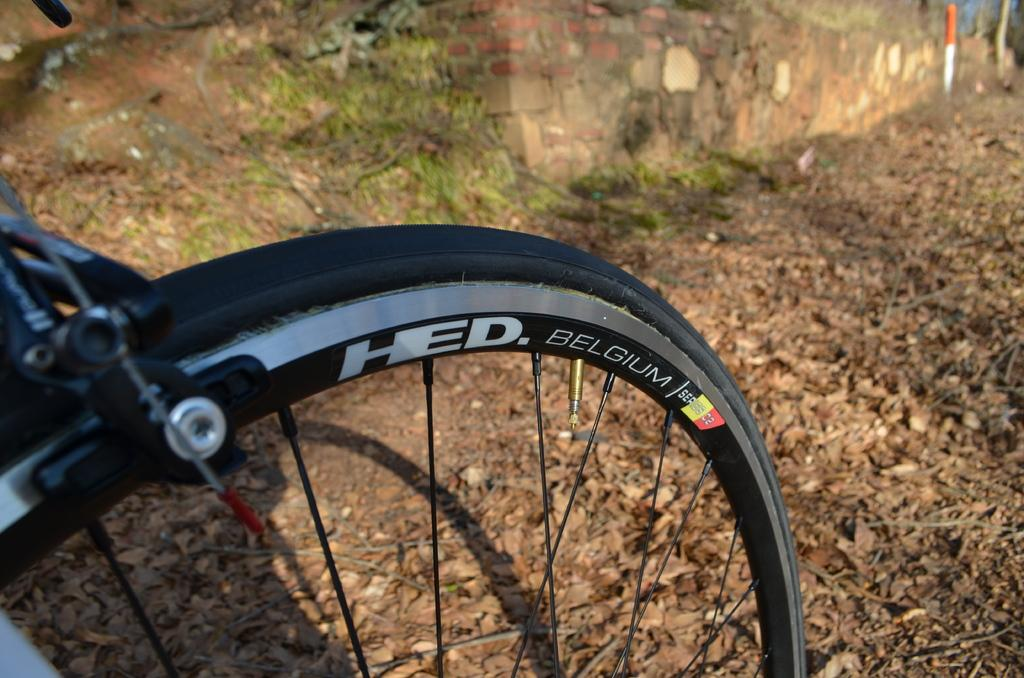What object is located in the bottom left of the image? There is a bicycle wheel in the bottom left of the image. What can be seen near the brick wall in the top left of the image? There is grass near a brick wall in the top left of the image. What type of vegetation is visible in the top right corner of the image? There are trees visible in the top right corner of the image. What part of the natural environment is visible in the top right corner of the image? The sky is visible in the top right corner of the image. What time of day is it in the image, and where is the hospital located? The time of day cannot be determined from the image, and there is no hospital present in the image. 